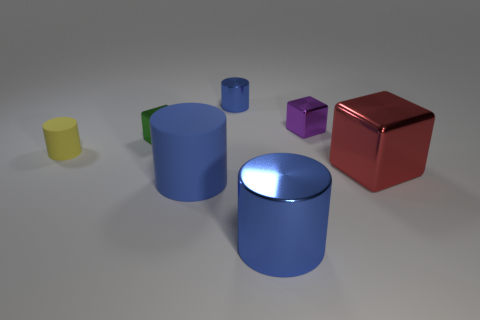Do the red thing and the rubber object on the right side of the green shiny cube have the same shape?
Give a very brief answer. No. What color is the cube that is both on the right side of the green shiny thing and in front of the purple cube?
Ensure brevity in your answer.  Red. What material is the large red cube in front of the cylinder that is on the left side of the large cylinder that is on the left side of the tiny blue thing?
Your response must be concise. Metal. What material is the tiny blue object?
Give a very brief answer. Metal. There is another rubber object that is the same shape as the big blue matte thing; what is its size?
Offer a terse response. Small. Does the large matte thing have the same color as the big shiny cylinder?
Keep it short and to the point. Yes. How many other objects are the same material as the tiny green thing?
Offer a terse response. 4. Are there an equal number of cubes in front of the large cube and small yellow cylinders?
Give a very brief answer. No. Do the rubber cylinder that is in front of the yellow matte cylinder and the tiny purple cube have the same size?
Offer a very short reply. No. What number of big red objects are right of the small blue object?
Make the answer very short. 1. 